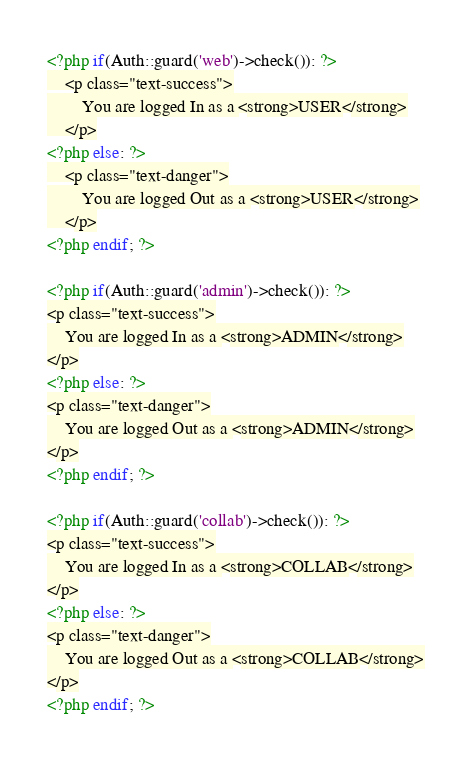<code> <loc_0><loc_0><loc_500><loc_500><_PHP_><?php if(Auth::guard('web')->check()): ?>
    <p class="text-success">
        You are logged In as a <strong>USER</strong>
    </p>
<?php else: ?>
    <p class="text-danger">
        You are logged Out as a <strong>USER</strong>
    </p>
<?php endif; ?>

<?php if(Auth::guard('admin')->check()): ?>
<p class="text-success">
    You are logged In as a <strong>ADMIN</strong>
</p>
<?php else: ?>
<p class="text-danger">
    You are logged Out as a <strong>ADMIN</strong>
</p>
<?php endif; ?>

<?php if(Auth::guard('collab')->check()): ?>
<p class="text-success">
    You are logged In as a <strong>COLLAB</strong>
</p>
<?php else: ?>
<p class="text-danger">
    You are logged Out as a <strong>COLLAB</strong>
</p>
<?php endif; ?>
</code> 